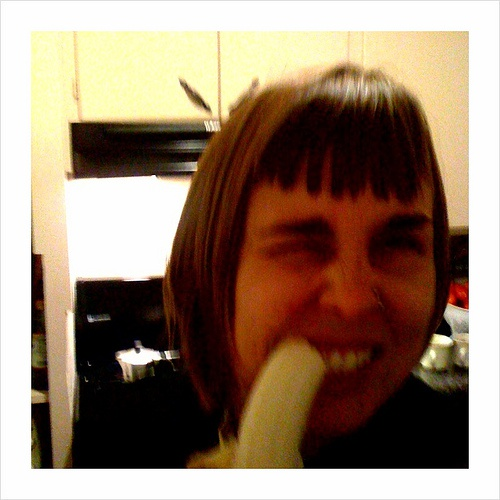Describe the objects in this image and their specific colors. I can see people in gainsboro, black, maroon, and olive tones, oven in gainsboro, black, white, maroon, and olive tones, banana in gainsboro, olive, and tan tones, cup in gainsboro, olive, khaki, and lightyellow tones, and bowl in gainsboro, beige, darkgray, lightgray, and gray tones in this image. 